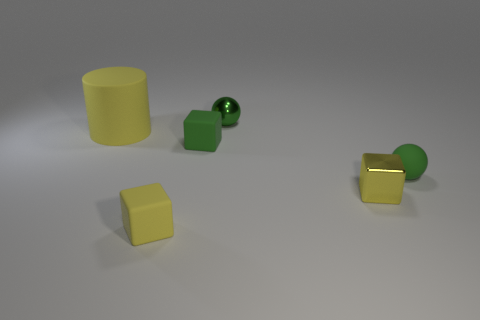Add 1 large red cubes. How many objects exist? 7 Subtract all balls. How many objects are left? 4 Add 4 tiny yellow metallic blocks. How many tiny yellow metallic blocks are left? 5 Add 6 purple objects. How many purple objects exist? 6 Subtract 0 cyan balls. How many objects are left? 6 Subtract all green matte cubes. Subtract all tiny rubber cubes. How many objects are left? 3 